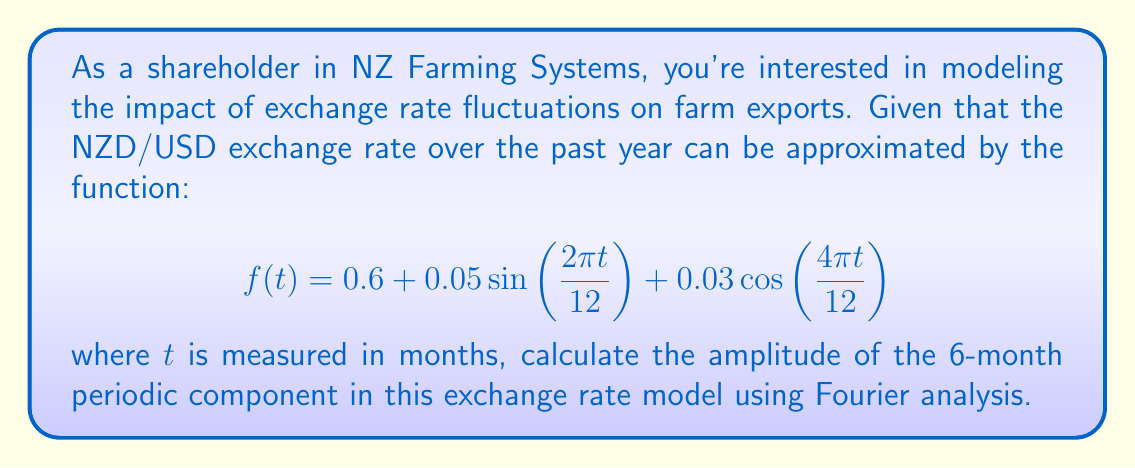Help me with this question. To solve this problem, we'll use Fourier analysis to identify and calculate the amplitude of the 6-month periodic component. Here's a step-by-step approach:

1) First, let's identify the frequencies in the given function:
   - $\frac{2\pi}{12}$ corresponds to a 12-month (annual) cycle
   - $\frac{4\pi}{12} = \frac{2\pi}{6}$ corresponds to a 6-month cycle

2) The 6-month cycle is represented by the cosine term: $0.03\cos(\frac{4\pi t}{12})$

3) In Fourier analysis, a general periodic function can be represented as:

   $$f(t) = a_0 + \sum_{n=1}^{\infty} (a_n\cos(n\omega t) + b_n\sin(n\omega t))$$

   where $\omega = \frac{2\pi}{T}$, and $T$ is the fundamental period.

4) Comparing our function to this general form, we can see that:
   - $a_0 = 0.6$ (the constant term)
   - For the 12-month cycle: $b_1 = 0.05$
   - For the 6-month cycle: $a_2 = 0.03$

5) The amplitude of a sinusoidal component is given by $\sqrt{a_n^2 + b_n^2}$

6) For the 6-month cycle, we have $a_2 = 0.03$ and $b_2 = 0$ (since there's no sine term for this frequency)

7) Therefore, the amplitude of the 6-month cycle is:

   $$A = \sqrt{(0.03)^2 + 0^2} = 0.03$$
Answer: The amplitude of the 6-month periodic component in the exchange rate model is 0.03. 